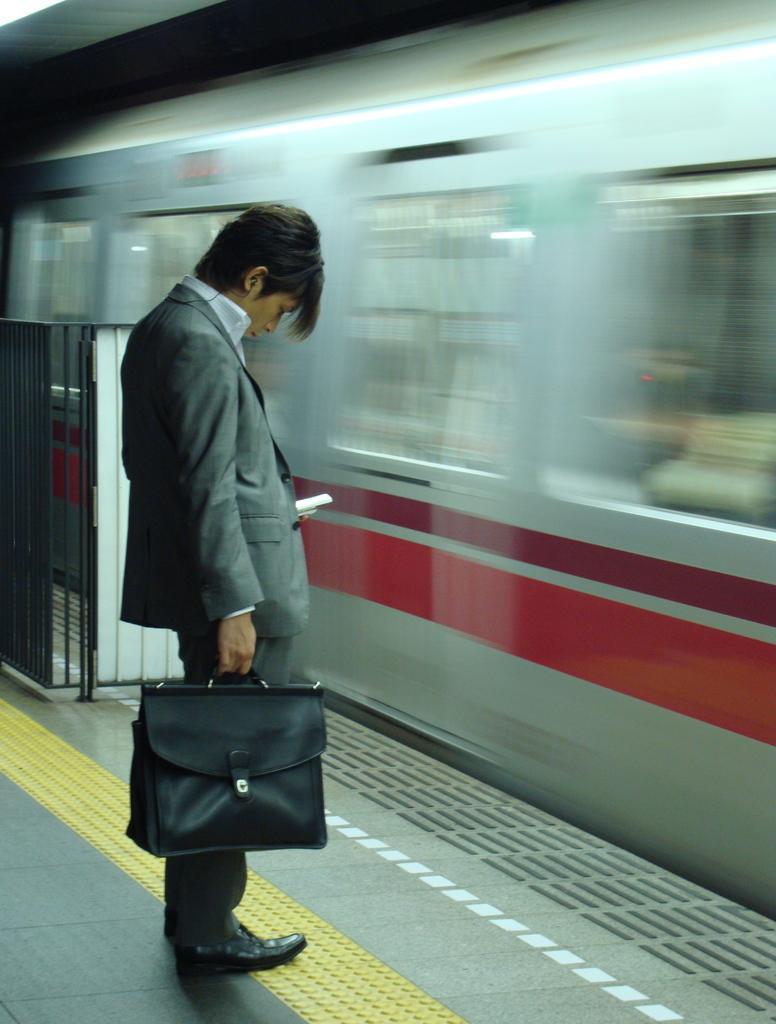Can you describe this image briefly? In this image, we can see a person holding an object. We can see the ground. We can also see a metal object. We can also see the train. 